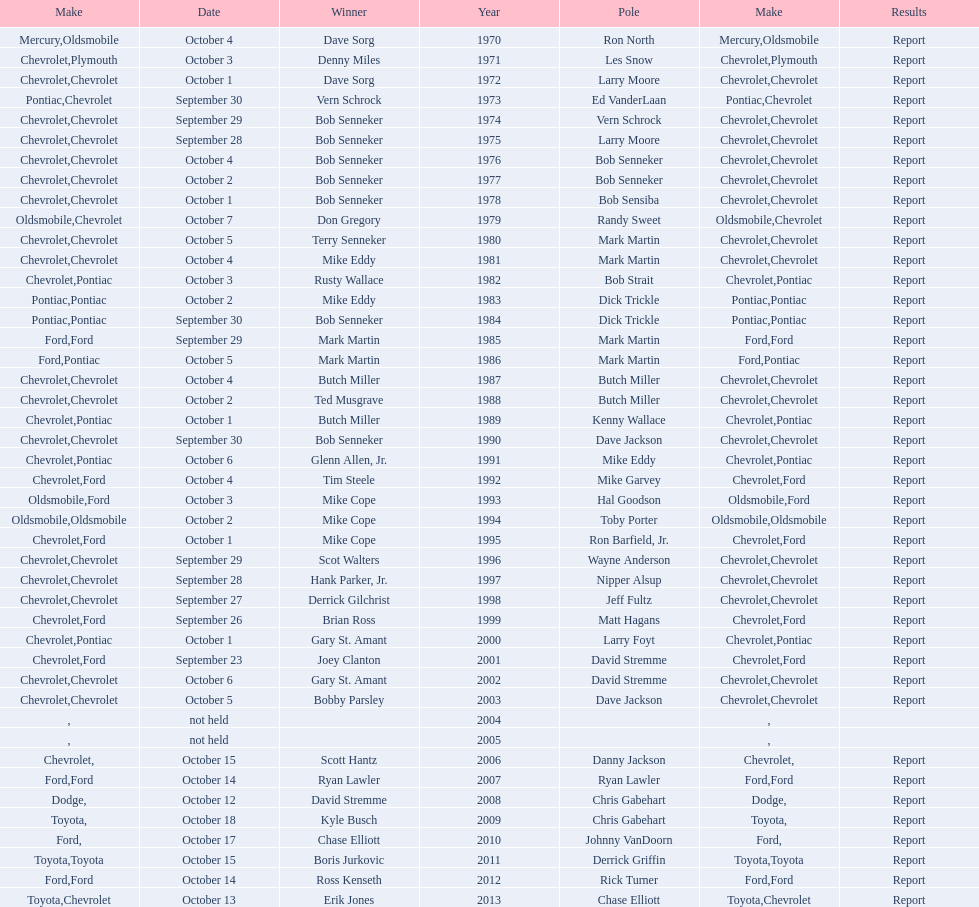Which make was used the least? Mercury. 